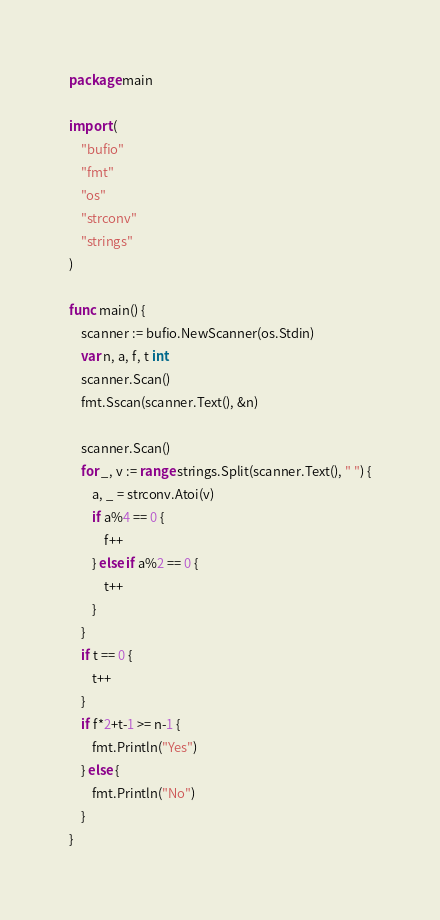<code> <loc_0><loc_0><loc_500><loc_500><_Go_>package main

import (
	"bufio"
	"fmt"
	"os"
	"strconv"
	"strings"
)

func main() {
	scanner := bufio.NewScanner(os.Stdin)
	var n, a, f, t int
	scanner.Scan()
	fmt.Sscan(scanner.Text(), &n)

	scanner.Scan()
	for _, v := range strings.Split(scanner.Text(), " ") {
		a, _ = strconv.Atoi(v)
		if a%4 == 0 {
			f++
		} else if a%2 == 0 {
			t++
		}
	}
	if t == 0 {
		t++
	}
	if f*2+t-1 >= n-1 {
		fmt.Println("Yes")
	} else {
		fmt.Println("No")
	}
}
</code> 